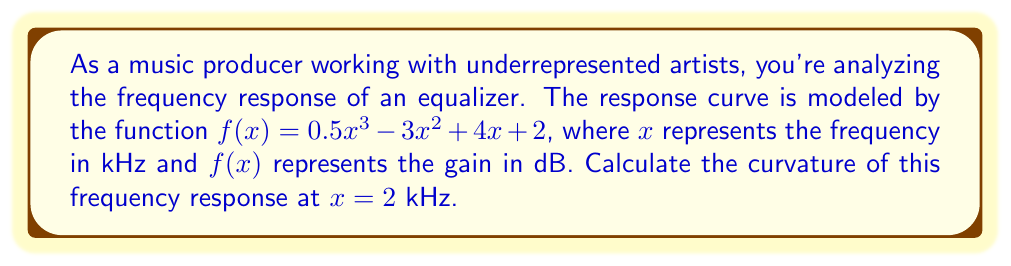Can you solve this math problem? To find the curvature of the frequency response curve at a specific point, we need to use the curvature formula:

$$\kappa = \frac{|f''(x)|}{(1 + [f'(x)]^2)^{3/2}}$$

Step 1: Find $f'(x)$
$$f'(x) = 1.5x^2 - 6x + 4$$

Step 2: Find $f''(x)$
$$f''(x) = 3x - 6$$

Step 3: Calculate $f'(2)$
$$f'(2) = 1.5(2)^2 - 6(2) + 4 = 6 - 12 + 4 = -2$$

Step 4: Calculate $f''(2)$
$$f''(2) = 3(2) - 6 = 0$$

Step 5: Apply the curvature formula
$$\kappa = \frac{|f''(2)|}{(1 + [f'(2)]^2)^{3/2}}$$
$$\kappa = \frac{|0|}{(1 + (-2)^2)^{3/2}}$$
$$\kappa = \frac{0}{(1 + 4)^{3/2}}$$
$$\kappa = \frac{0}{5^{3/2}}$$
$$\kappa = 0$$
Answer: $0$ 